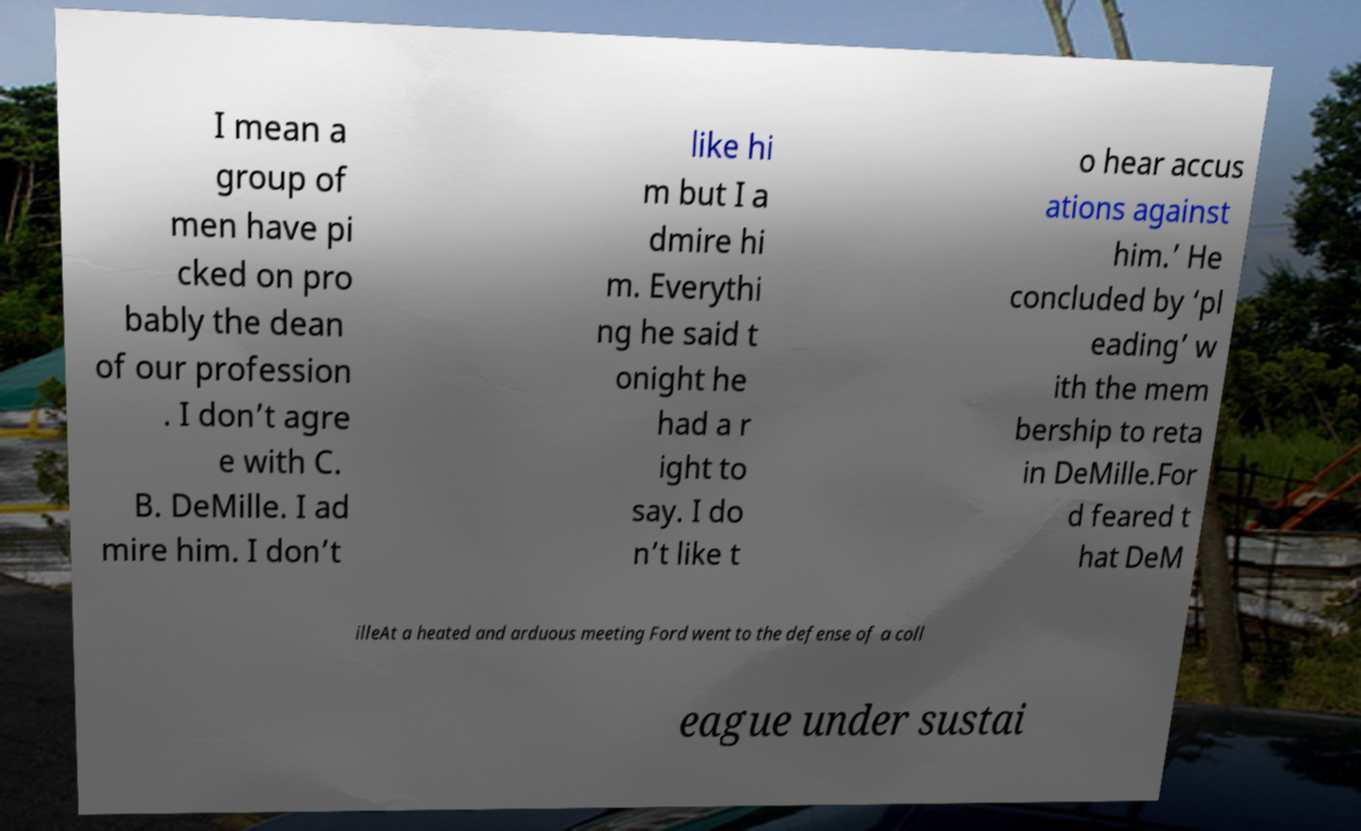I need the written content from this picture converted into text. Can you do that? I mean a group of men have pi cked on pro bably the dean of our profession . I don’t agre e with C. B. DeMille. I ad mire him. I don’t like hi m but I a dmire hi m. Everythi ng he said t onight he had a r ight to say. I do n’t like t o hear accus ations against him.’ He concluded by ‘pl eading’ w ith the mem bership to reta in DeMille.For d feared t hat DeM illeAt a heated and arduous meeting Ford went to the defense of a coll eague under sustai 